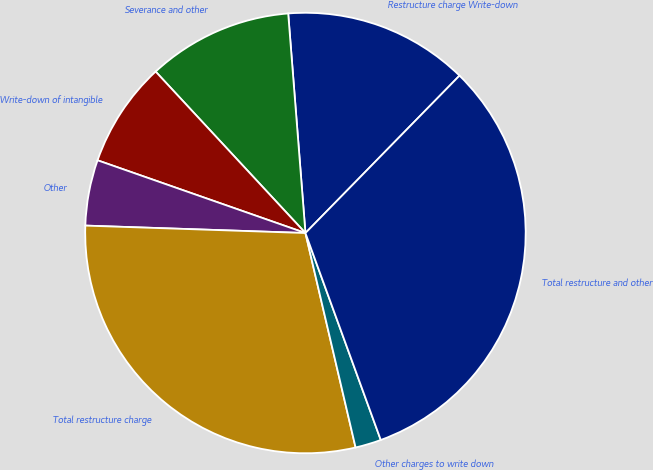Convert chart. <chart><loc_0><loc_0><loc_500><loc_500><pie_chart><fcel>Restructure charge Write-down<fcel>Severance and other<fcel>Write-down of intangible<fcel>Other<fcel>Total restructure charge<fcel>Other charges to write down<fcel>Total restructure and other<nl><fcel>13.58%<fcel>10.66%<fcel>7.74%<fcel>4.82%<fcel>29.2%<fcel>1.9%<fcel>32.12%<nl></chart> 